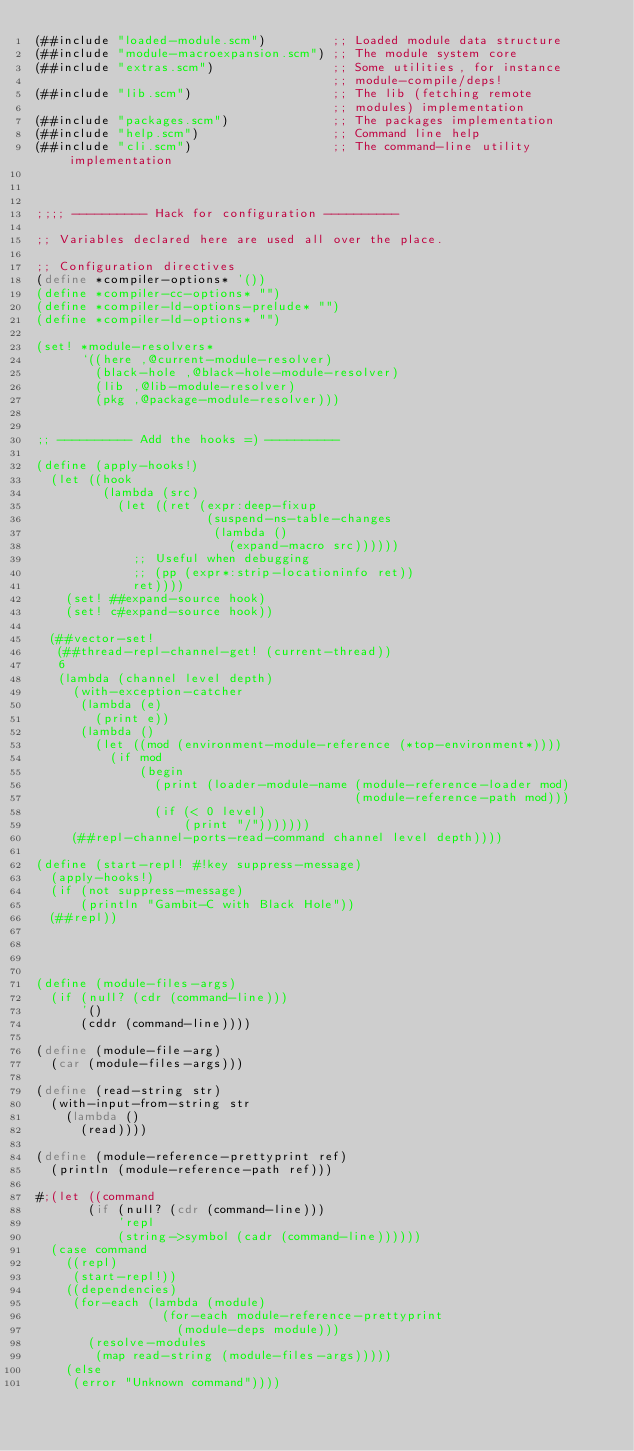Convert code to text. <code><loc_0><loc_0><loc_500><loc_500><_Scheme_>(##include "loaded-module.scm")         ;; Loaded module data structure
(##include "module-macroexpansion.scm") ;; The module system core
(##include "extras.scm")                ;; Some utilities, for instance
                                        ;; module-compile/deps!
(##include "lib.scm")                   ;; The lib (fetching remote
                                        ;; modules) implementation
(##include "packages.scm")              ;; The packages implementation
(##include "help.scm")                  ;; Command line help
(##include "cli.scm")                   ;; The command-line utility implementation



;;;; ---------- Hack for configuration ----------

;; Variables declared here are used all over the place.

;; Configuration directives
(define *compiler-options* '())
(define *compiler-cc-options* "")
(define *compiler-ld-options-prelude* "")
(define *compiler-ld-options* "")

(set! *module-resolvers*
      `((here ,@current-module-resolver)
        (black-hole ,@black-hole-module-resolver)
        (lib ,@lib-module-resolver)
        (pkg ,@package-module-resolver)))


;; ---------- Add the hooks =) ----------

(define (apply-hooks!)
  (let ((hook
         (lambda (src)
           (let ((ret (expr:deep-fixup
                       (suspend-ns-table-changes
                        (lambda ()
                          (expand-macro src))))))
             ;; Useful when debugging
             ;; (pp (expr*:strip-locationinfo ret))
             ret))))
    (set! ##expand-source hook)
    (set! c#expand-source hook))

  (##vector-set!
   (##thread-repl-channel-get! (current-thread))
   6
   (lambda (channel level depth)
     (with-exception-catcher
      (lambda (e)
        (print e))
      (lambda ()
        (let ((mod (environment-module-reference (*top-environment*))))
          (if mod
              (begin
                (print (loader-module-name (module-reference-loader mod)
                                           (module-reference-path mod)))
                (if (< 0 level)
                    (print "/")))))))
     (##repl-channel-ports-read-command channel level depth))))

(define (start-repl! #!key suppress-message)
  (apply-hooks!)
  (if (not suppress-message)
      (println "Gambit-C with Black Hole"))
  (##repl))




(define (module-files-args)
  (if (null? (cdr (command-line)))
      '()
      (cddr (command-line))))

(define (module-file-arg)
  (car (module-files-args)))

(define (read-string str)
  (with-input-from-string str
    (lambda ()
      (read))))

(define (module-reference-prettyprint ref)
  (println (module-reference-path ref)))

#;(let ((command
       (if (null? (cdr (command-line)))
           'repl
           (string->symbol (cadr (command-line))))))
  (case command
    ((repl)
     (start-repl!))
    ((dependencies)
     (for-each (lambda (module)
                 (for-each module-reference-prettyprint
                   (module-deps module)))
       (resolve-modules
        (map read-string (module-files-args)))))
    (else
     (error "Unknown command"))))
</code> 